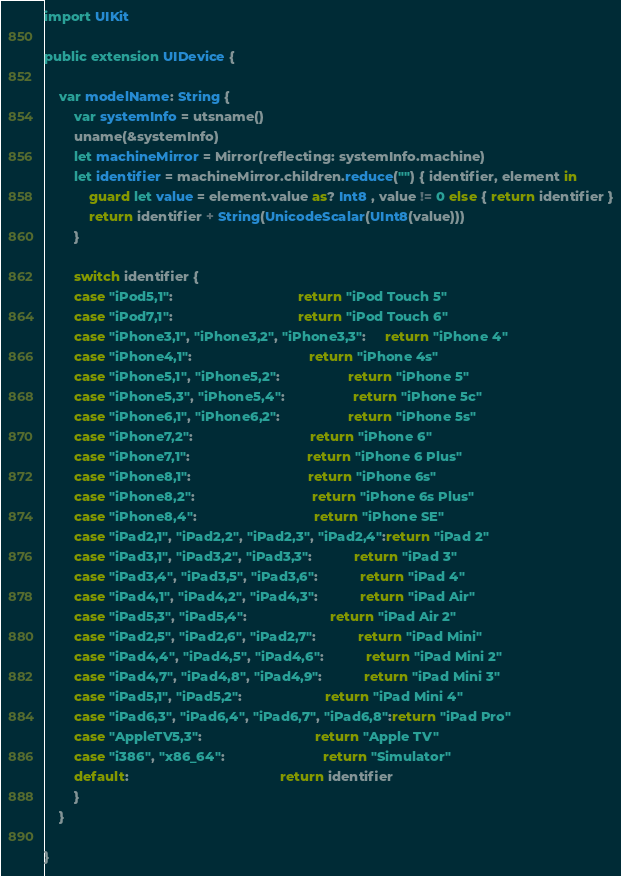Convert code to text. <code><loc_0><loc_0><loc_500><loc_500><_Swift_>


import UIKit

public extension UIDevice {
    
    var modelName: String {
        var systemInfo = utsname()
        uname(&systemInfo)
        let machineMirror = Mirror(reflecting: systemInfo.machine)
        let identifier = machineMirror.children.reduce("") { identifier, element in
            guard let value = element.value as? Int8 , value != 0 else { return identifier }
            return identifier + String(UnicodeScalar(UInt8(value)))
        }
        
        switch identifier {
        case "iPod5,1":                                 return "iPod Touch 5"
        case "iPod7,1":                                 return "iPod Touch 6"
        case "iPhone3,1", "iPhone3,2", "iPhone3,3":     return "iPhone 4"
        case "iPhone4,1":                               return "iPhone 4s"
        case "iPhone5,1", "iPhone5,2":                  return "iPhone 5"
        case "iPhone5,3", "iPhone5,4":                  return "iPhone 5c"
        case "iPhone6,1", "iPhone6,2":                  return "iPhone 5s"
        case "iPhone7,2":                               return "iPhone 6"
        case "iPhone7,1":                               return "iPhone 6 Plus"
        case "iPhone8,1":                               return "iPhone 6s"
        case "iPhone8,2":                               return "iPhone 6s Plus"
        case "iPhone8,4":                               return "iPhone SE"
        case "iPad2,1", "iPad2,2", "iPad2,3", "iPad2,4":return "iPad 2"
        case "iPad3,1", "iPad3,2", "iPad3,3":           return "iPad 3"
        case "iPad3,4", "iPad3,5", "iPad3,6":           return "iPad 4"
        case "iPad4,1", "iPad4,2", "iPad4,3":           return "iPad Air"
        case "iPad5,3", "iPad5,4":                      return "iPad Air 2"
        case "iPad2,5", "iPad2,6", "iPad2,7":           return "iPad Mini"
        case "iPad4,4", "iPad4,5", "iPad4,6":           return "iPad Mini 2"
        case "iPad4,7", "iPad4,8", "iPad4,9":           return "iPad Mini 3"
        case "iPad5,1", "iPad5,2":                      return "iPad Mini 4"
        case "iPad6,3", "iPad6,4", "iPad6,7", "iPad6,8":return "iPad Pro"
        case "AppleTV5,3":                              return "Apple TV"
        case "i386", "x86_64":                          return "Simulator"
        default:                                        return identifier
        }
    }
    
}
</code> 